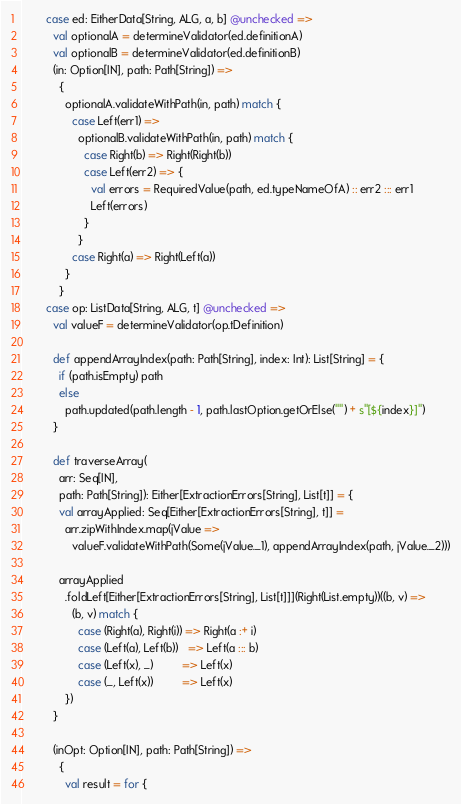Convert code to text. <code><loc_0><loc_0><loc_500><loc_500><_Scala_>        case ed: EitherData[String, ALG, a, b] @unchecked =>
          val optionalA = determineValidator(ed.definitionA)
          val optionalB = determineValidator(ed.definitionB)
          (in: Option[IN], path: Path[String]) =>
            {
              optionalA.validateWithPath(in, path) match {
                case Left(err1) =>
                  optionalB.validateWithPath(in, path) match {
                    case Right(b) => Right(Right(b))
                    case Left(err2) => {
                      val errors = RequiredValue(path, ed.typeNameOfA) :: err2 ::: err1
                      Left(errors)
                    }
                  }
                case Right(a) => Right(Left(a))
              }
            }
        case op: ListData[String, ALG, t] @unchecked =>
          val valueF = determineValidator(op.tDefinition)

          def appendArrayIndex(path: Path[String], index: Int): List[String] = {
            if (path.isEmpty) path
            else
              path.updated(path.length - 1, path.lastOption.getOrElse("") + s"[${index}]")
          }

          def traverseArray(
            arr: Seq[IN],
            path: Path[String]): Either[ExtractionErrors[String], List[t]] = {
            val arrayApplied: Seq[Either[ExtractionErrors[String], t]] =
              arr.zipWithIndex.map(jValue =>
                valueF.validateWithPath(Some(jValue._1), appendArrayIndex(path, jValue._2)))

            arrayApplied
              .foldLeft[Either[ExtractionErrors[String], List[t]]](Right(List.empty))((b, v) =>
                (b, v) match {
                  case (Right(a), Right(i)) => Right(a :+ i)
                  case (Left(a), Left(b))   => Left(a ::: b)
                  case (Left(x), _)         => Left(x)
                  case (_, Left(x))         => Left(x)
              })
          }

          (inOpt: Option[IN], path: Path[String]) =>
            {
              val result = for {</code> 